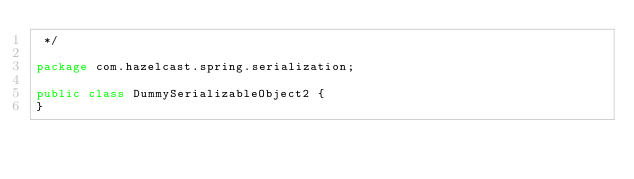Convert code to text. <code><loc_0><loc_0><loc_500><loc_500><_Java_> */

package com.hazelcast.spring.serialization;

public class DummySerializableObject2 {
}
</code> 